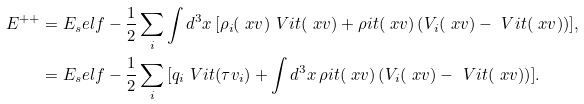Convert formula to latex. <formula><loc_0><loc_0><loc_500><loc_500>E ^ { + + } & = E _ { s } e l f - \frac { 1 } { 2 } \sum _ { i } { \int { d ^ { 3 } x \, [ \rho _ { i } ( \ x v ) \ V i t ( \ x v ) + \rho i t ( \ x v ) \left ( V _ { i } ( \ x v ) - \ V i t ( \ x v ) \right ) ] } } , \\ & = E _ { s } e l f - \frac { 1 } { 2 } \sum _ { i } { [ q _ { i } \ V i t ( \tau v _ { i } ) + \int { d ^ { 3 } x \, \rho i t ( \ x v ) \left ( V _ { i } ( \ x v ) - \ V i t ( \ x v ) \right ) } ] } .</formula> 